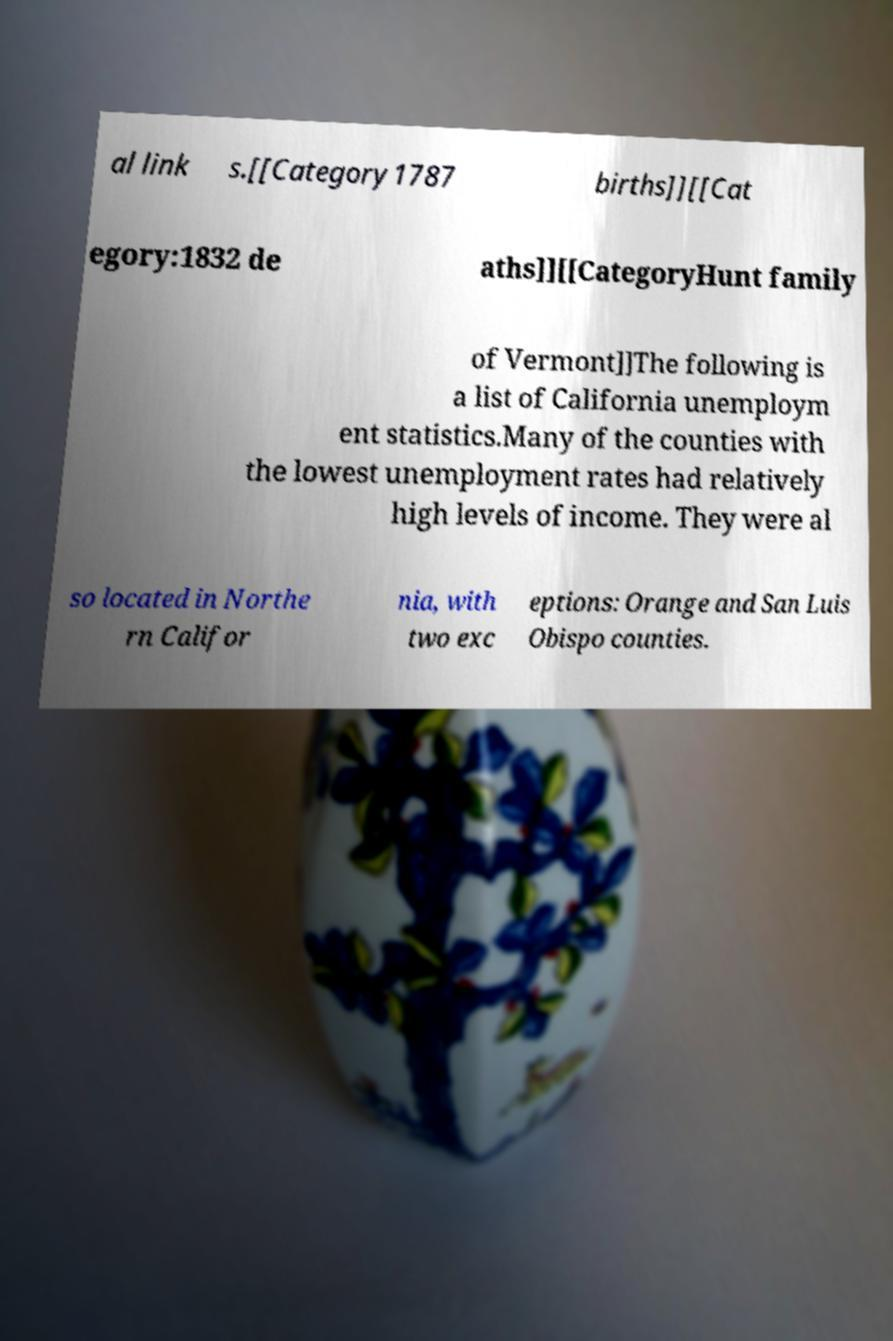Can you read and provide the text displayed in the image?This photo seems to have some interesting text. Can you extract and type it out for me? al link s.[[Category1787 births]][[Cat egory:1832 de aths]][[CategoryHunt family of Vermont]]The following is a list of California unemploym ent statistics.Many of the counties with the lowest unemployment rates had relatively high levels of income. They were al so located in Northe rn Califor nia, with two exc eptions: Orange and San Luis Obispo counties. 